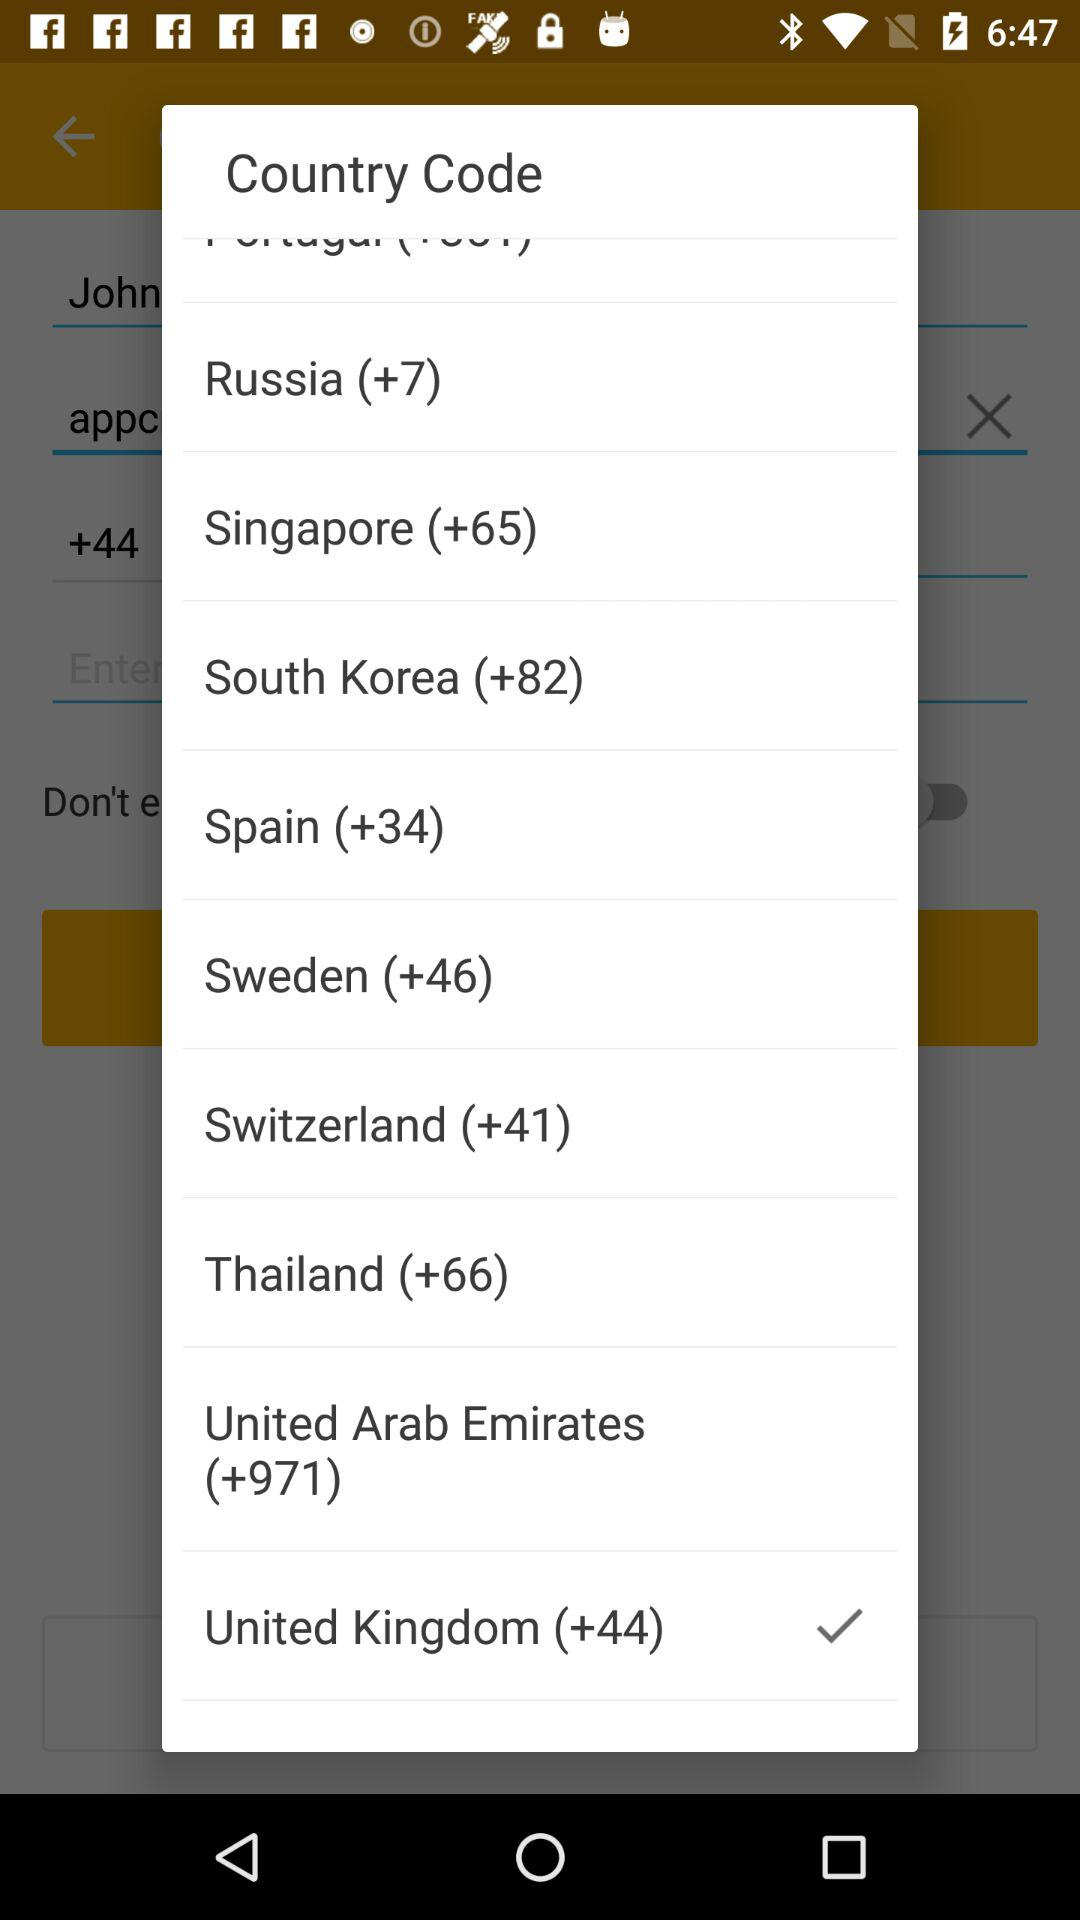Which country code is selected? The selected country code is +44. 